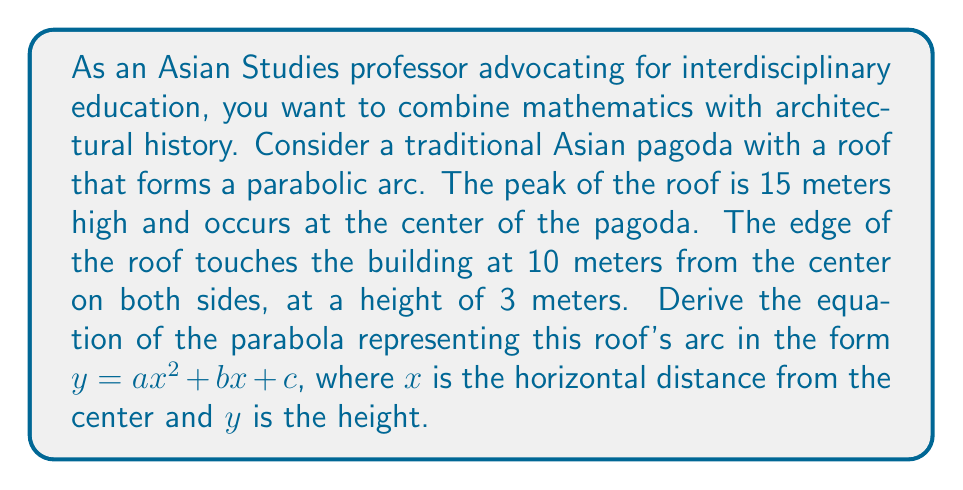Teach me how to tackle this problem. Let's approach this step-by-step:

1) The general form of a parabola is $y = ax^2 + bx + c$, where $a$, $b$, and $c$ are constants we need to determine.

2) We know three points on this parabola:
   - The peak: (0, 15)
   - The left edge: (-10, 3)
   - The right edge: (10, 3)

3) The parabola is symmetric about the y-axis (the center of the pagoda), so $b$ must be 0. Our equation simplifies to $y = ax^2 + c$.

4) Using the peak point (0, 15):
   $15 = a(0)^2 + c$
   $c = 15$

5) Our equation is now $y = ax^2 + 15$

6) Using either edge point, let's use (10, 3):
   $3 = a(10)^2 + 15$
   $3 = 100a + 15$
   $-12 = 100a$
   $a = -\frac{12}{100} = -\frac{3}{25} = -0.12$

7) Therefore, our final equation is:

   $y = -\frac{3}{25}x^2 + 15$

This equation represents the parabolic arc of the pagoda roof, where $x$ is the horizontal distance from the center in meters, and $y$ is the height in meters.
Answer: $y = -\frac{3}{25}x^2 + 15$ 